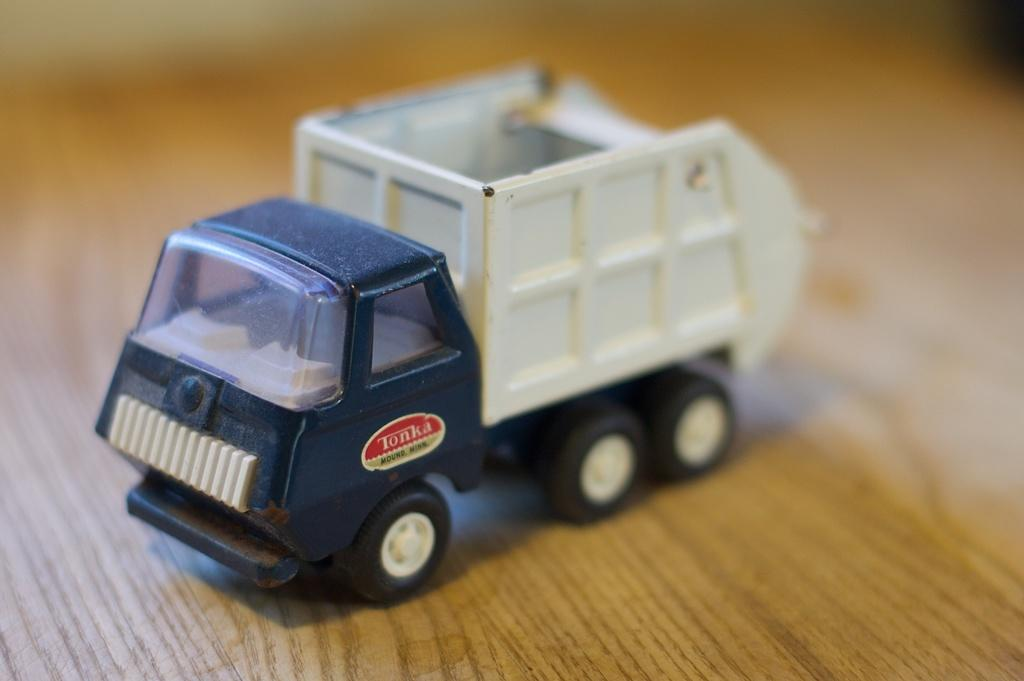What is the main object in the image? There is a toy vehicle in the image. What type of surface is the toy vehicle on? The toy vehicle is on a wooden floor. What type of tray is the toy vehicle placed on in the image? There is no tray present in the image; the toy vehicle is directly on the wooden floor. 